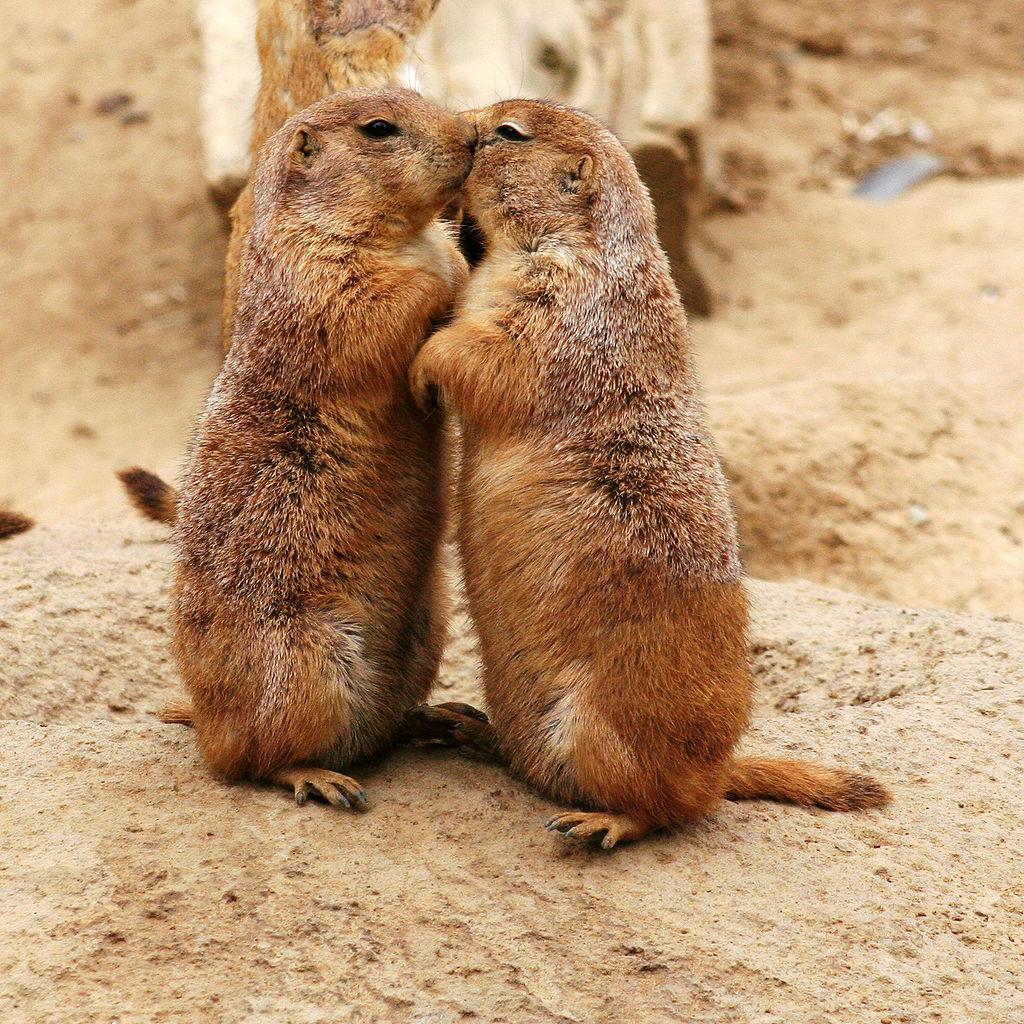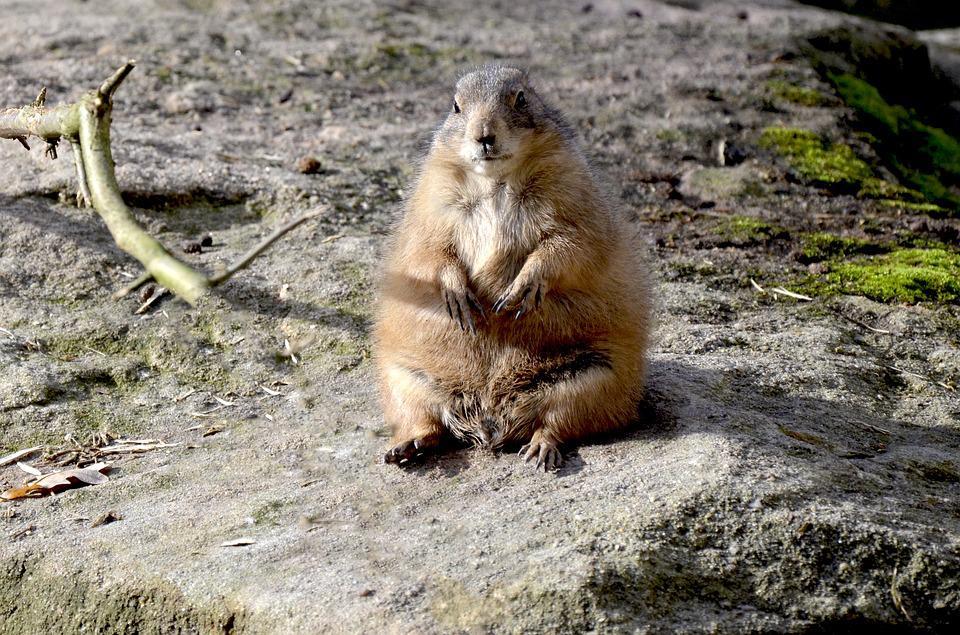The first image is the image on the left, the second image is the image on the right. Assess this claim about the two images: "There is a total of 4 prairie dogs.". Correct or not? Answer yes or no. No. The first image is the image on the left, the second image is the image on the right. For the images shown, is this caption "The animals are facing each other in both images." true? Answer yes or no. No. 